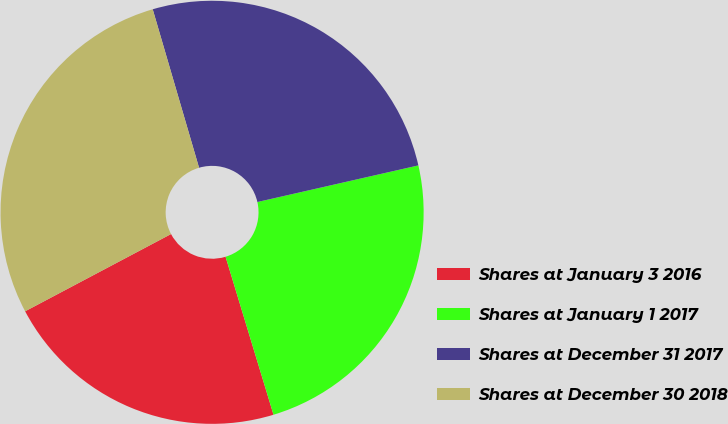Convert chart. <chart><loc_0><loc_0><loc_500><loc_500><pie_chart><fcel>Shares at January 3 2016<fcel>Shares at January 1 2017<fcel>Shares at December 31 2017<fcel>Shares at December 30 2018<nl><fcel>21.94%<fcel>23.87%<fcel>25.97%<fcel>28.22%<nl></chart> 